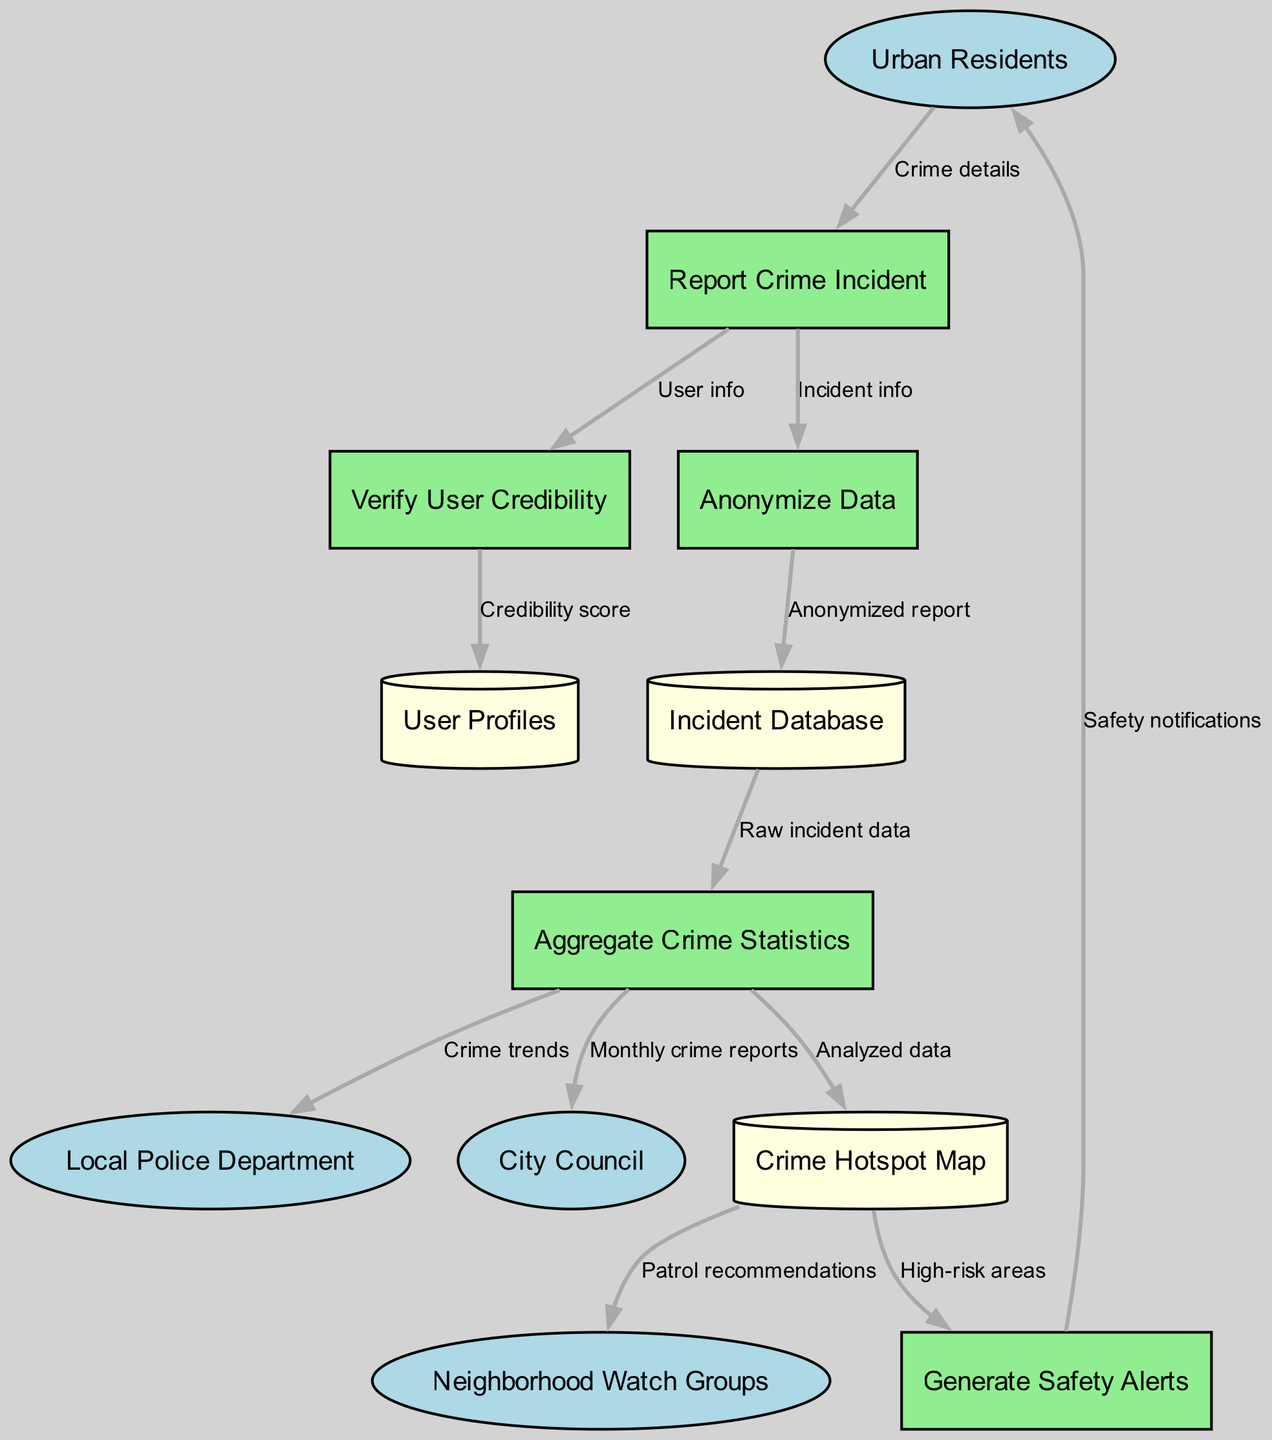What is the total number of external entities in the diagram? The diagram lists four external entities: Urban Residents, Local Police Department, City Council, and Neighborhood Watch Groups. Counting these gives a total of four external entities.
Answer: 4 Which process receives the "Crime details" data flow? The data flow labeled "Crime details" originates from Urban Residents and is directed towards the process called "Report Crime Incident." Thus, this process receives the crime details.
Answer: Report Crime Incident How many data stores are present in the diagram? The diagram features three data stores: User Profiles, Incident Database, and Crime Hotspot Map. Adding these gives a total of three data stores.
Answer: 3 What type of information is transferred from the "Aggregate Crime Statistics" process to the "Local Police Department"? The information transferred is labeled "Crime trends," which indicates that the aggregated crime statistics provide insights into the evolving crime patterns to the police.
Answer: Crime trends Which entity receives safety notifications? The process "Generate Safety Alerts" sends safety notifications to Urban Residents. Therefore, Urban Residents receive the safety notifications.
Answer: Urban Residents What is the flow direction of the data between "Anonymize Data" and "Incident Database"? The flow direction is from "Anonymize Data" to "Incident Database," where the anonymized report is stored in the incident database.
Answer: Anonymize Data to Incident Database Which process is directly connected to the data store called "Crime Hotspot Map"? The process "Aggregate Crime Statistics" sends analyzed data to the "Crime Hotspot Map," which signifies a direct connection to this process.
Answer: Aggregate Crime Statistics What kind of recommendations does the "Crime Hotspot Map" provide to Neighborhood Watch Groups? The flow from "Crime Hotspot Map" to "Neighborhood Watch Groups" is labeled "Patrol recommendations," which indicates the kind of information being shared.
Answer: Patrol recommendations How is user credibility determined in the app? The flow of data from "Report Crime Incident" to "Verify User Credibility" shows that the process verifies user information to assess their credibility. Thus, user credibility is determined through verification of user info.
Answer: Verify User Credibility 